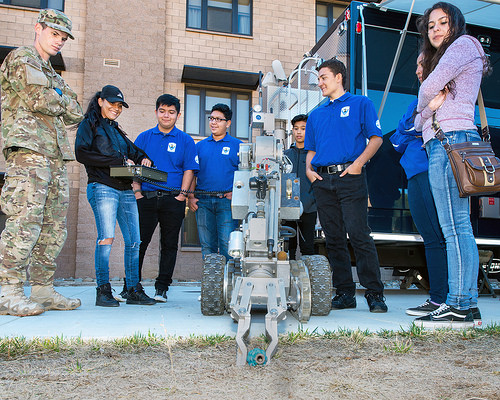<image>
Is the hat above the coat? Yes. The hat is positioned above the coat in the vertical space, higher up in the scene. 